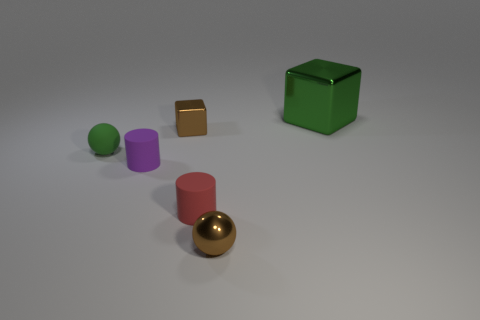Add 1 big red metallic things. How many objects exist? 7 Subtract all cylinders. How many objects are left? 4 Subtract all purple cylinders. Subtract all small red matte cylinders. How many objects are left? 4 Add 3 large green objects. How many large green objects are left? 4 Add 6 tiny green objects. How many tiny green objects exist? 7 Subtract 0 red cubes. How many objects are left? 6 